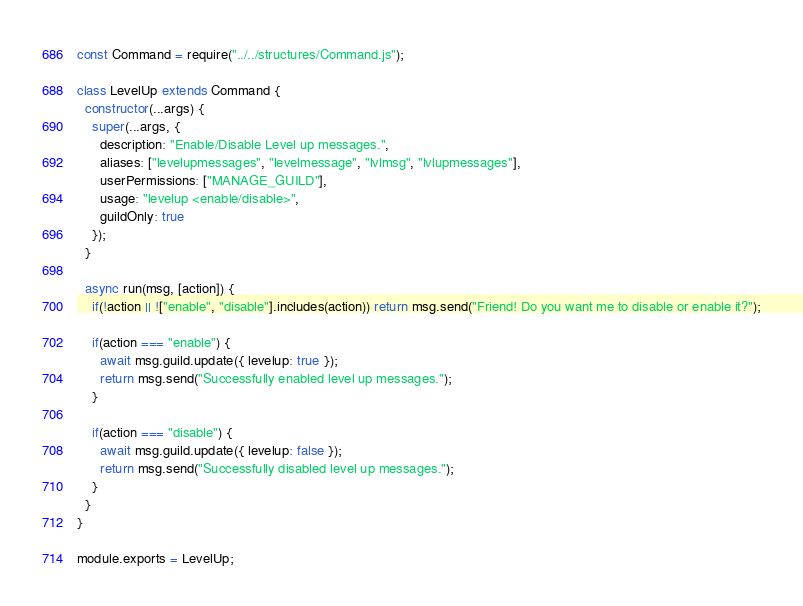<code> <loc_0><loc_0><loc_500><loc_500><_JavaScript_>const Command = require("../../structures/Command.js");

class LevelUp extends Command {
  constructor(...args) {
    super(...args, {
      description: "Enable/Disable Level up messages.",
      aliases: ["levelupmessages", "levelmessage", "lvlmsg", "lvlupmessages"],
      userPermissions: ["MANAGE_GUILD"],
      usage: "levelup <enable/disable>",
      guildOnly: true
    });
  }

  async run(msg, [action]) {
    if(!action || !["enable", "disable"].includes(action)) return msg.send("Friend! Do you want me to disable or enable it?");

    if(action === "enable") {
      await msg.guild.update({ levelup: true });
      return msg.send("Successfully enabled level up messages.");
    }

    if(action === "disable") {
      await msg.guild.update({ levelup: false });
      return msg.send("Successfully disabled level up messages.");
    }
  }
}

module.exports = LevelUp;
</code> 